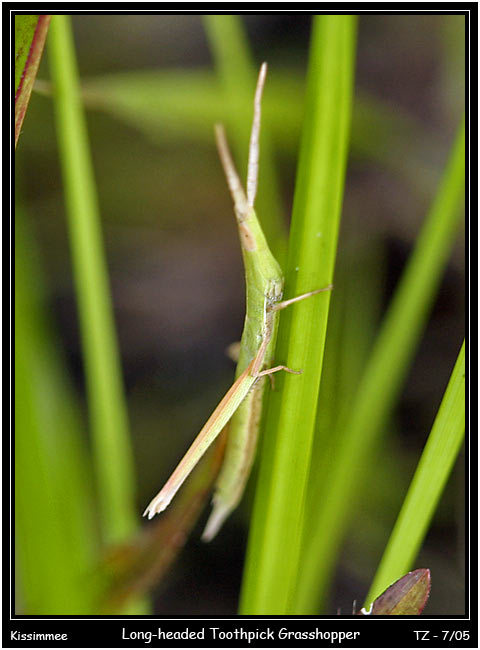How does the appearance of the Long-headed Toothpick Grasshopper benefit it in terms of behavior or survival strategy? The Long-headed Toothpick Grasshopper's appearance serves as a phenomenal survival strategy. Its elongated and slender body, mirroring the twigs and stems it lives among, allows it to remain virtually invisible to both predators and prey. Behaviorally, this means the grasshopper can feed and move rather undisturbed. Additionally, it may remain motionless for long periods, further blending in with its surroundings. When it does detect danger, its stick-like physique enables a quick and streamlined escape, as it can dart among the vegetation with minimum visual disturbance. Evolution has fine-tuned this species not just for survival, but for successful reproduction and stealthy predation as well. 